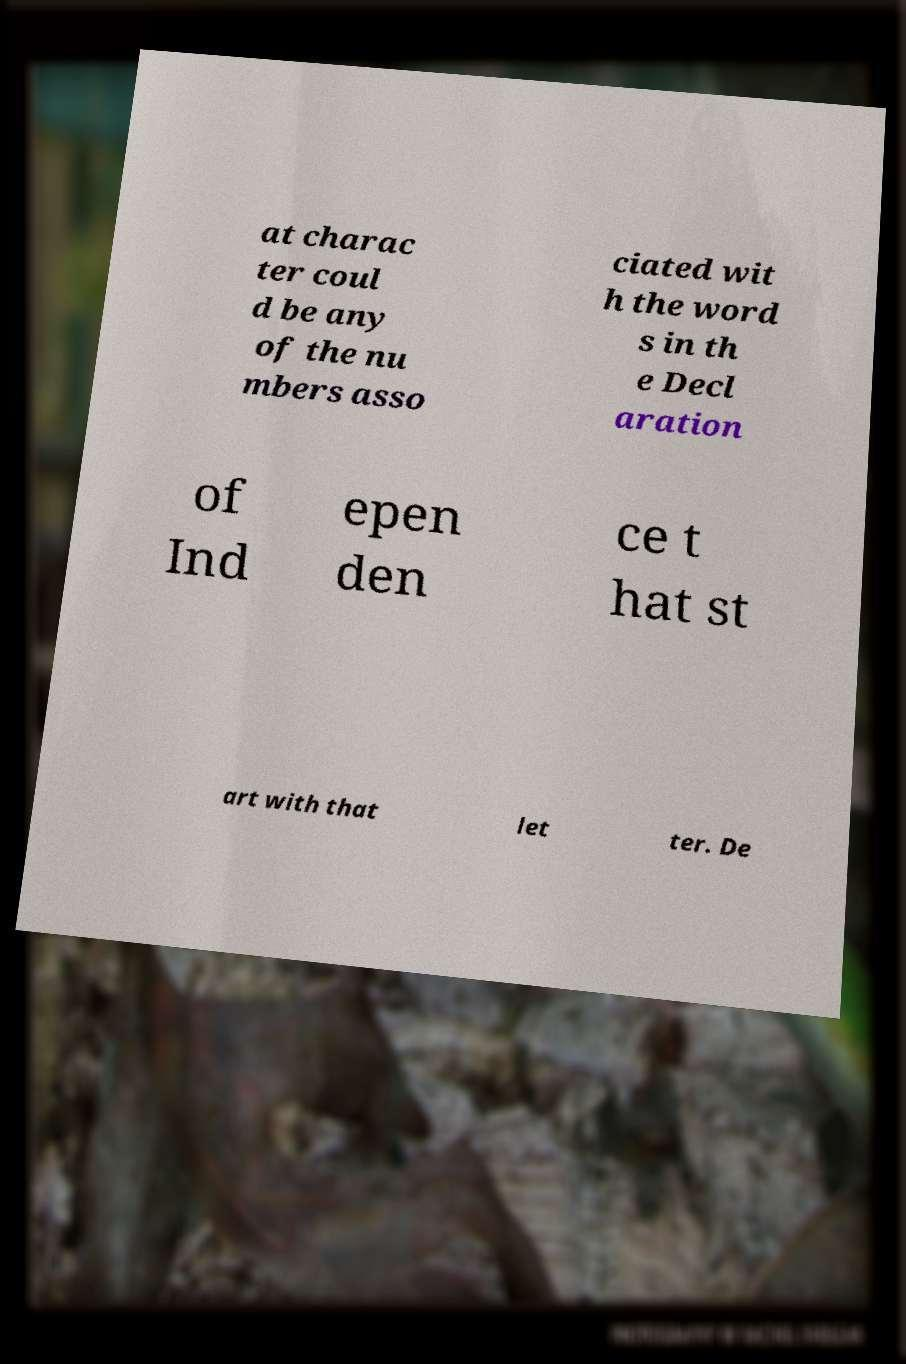What messages or text are displayed in this image? I need them in a readable, typed format. at charac ter coul d be any of the nu mbers asso ciated wit h the word s in th e Decl aration of Ind epen den ce t hat st art with that let ter. De 